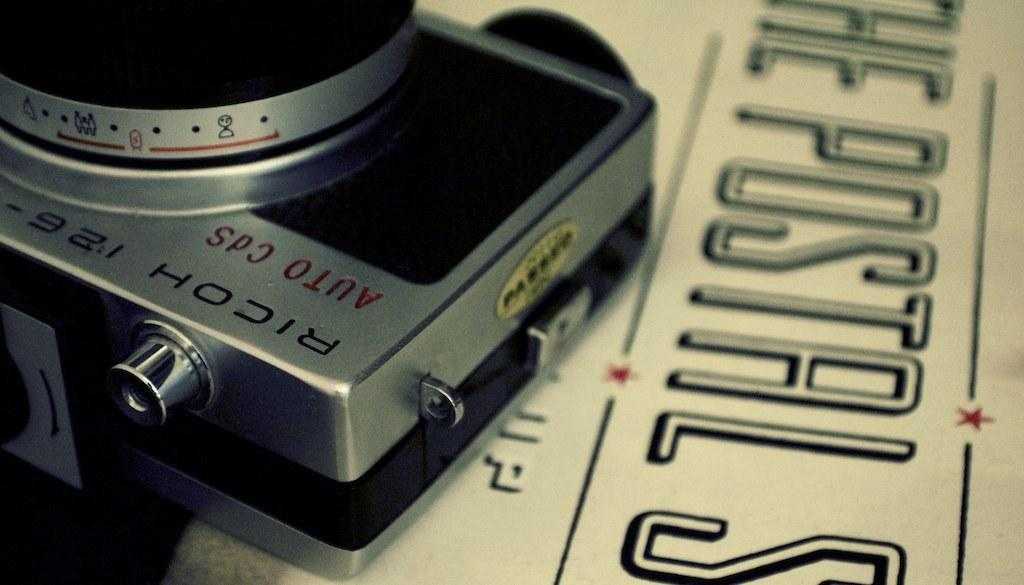What object is the main focus of the image? There is a camera in the image. Where is the camera placed? The camera is placed on a newspaper. What can be observed about the newspaper? There is text in black color on the newspaper. Can you tell me how many donkeys are visible in the image? There are no donkeys present in the image. What type of goat is featured in the text on the newspaper? There is no mention of a goat in the text on the newspaper. 